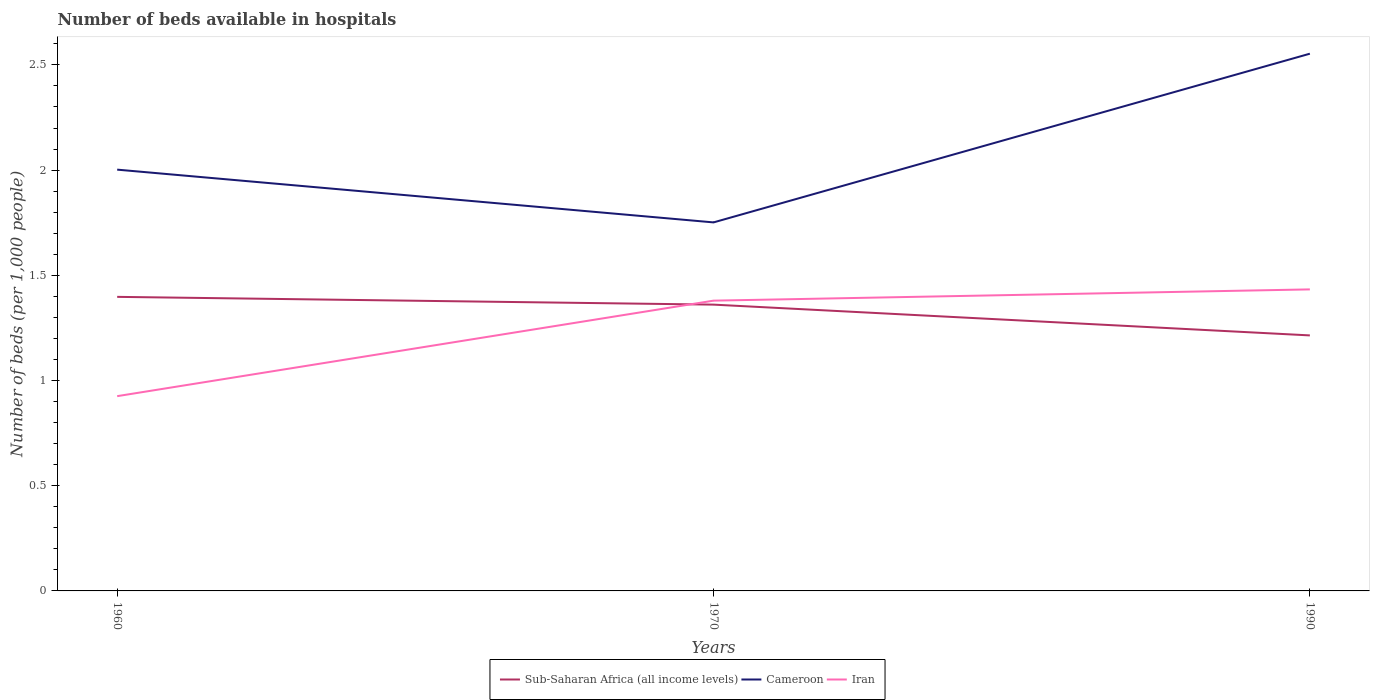How many different coloured lines are there?
Provide a succinct answer. 3. Does the line corresponding to Iran intersect with the line corresponding to Sub-Saharan Africa (all income levels)?
Give a very brief answer. Yes. Is the number of lines equal to the number of legend labels?
Keep it short and to the point. Yes. Across all years, what is the maximum number of beds in the hospiatls of in Cameroon?
Provide a short and direct response. 1.75. What is the total number of beds in the hospiatls of in Iran in the graph?
Keep it short and to the point. -0.05. What is the difference between the highest and the second highest number of beds in the hospiatls of in Iran?
Provide a short and direct response. 0.51. What is the difference between the highest and the lowest number of beds in the hospiatls of in Sub-Saharan Africa (all income levels)?
Offer a very short reply. 2. What is the difference between two consecutive major ticks on the Y-axis?
Keep it short and to the point. 0.5. Where does the legend appear in the graph?
Give a very brief answer. Bottom center. How are the legend labels stacked?
Give a very brief answer. Horizontal. What is the title of the graph?
Ensure brevity in your answer.  Number of beds available in hospitals. Does "Grenada" appear as one of the legend labels in the graph?
Offer a terse response. No. What is the label or title of the Y-axis?
Your answer should be compact. Number of beds (per 1,0 people). What is the Number of beds (per 1,000 people) in Sub-Saharan Africa (all income levels) in 1960?
Give a very brief answer. 1.4. What is the Number of beds (per 1,000 people) in Cameroon in 1960?
Provide a short and direct response. 2. What is the Number of beds (per 1,000 people) of Iran in 1960?
Ensure brevity in your answer.  0.93. What is the Number of beds (per 1,000 people) in Sub-Saharan Africa (all income levels) in 1970?
Give a very brief answer. 1.36. What is the Number of beds (per 1,000 people) of Cameroon in 1970?
Make the answer very short. 1.75. What is the Number of beds (per 1,000 people) in Iran in 1970?
Provide a succinct answer. 1.38. What is the Number of beds (per 1,000 people) in Sub-Saharan Africa (all income levels) in 1990?
Provide a short and direct response. 1.21. What is the Number of beds (per 1,000 people) in Cameroon in 1990?
Keep it short and to the point. 2.55. What is the Number of beds (per 1,000 people) in Iran in 1990?
Ensure brevity in your answer.  1.43. Across all years, what is the maximum Number of beds (per 1,000 people) in Sub-Saharan Africa (all income levels)?
Provide a succinct answer. 1.4. Across all years, what is the maximum Number of beds (per 1,000 people) in Cameroon?
Offer a very short reply. 2.55. Across all years, what is the maximum Number of beds (per 1,000 people) of Iran?
Offer a terse response. 1.43. Across all years, what is the minimum Number of beds (per 1,000 people) in Sub-Saharan Africa (all income levels)?
Offer a terse response. 1.21. Across all years, what is the minimum Number of beds (per 1,000 people) in Cameroon?
Make the answer very short. 1.75. Across all years, what is the minimum Number of beds (per 1,000 people) in Iran?
Make the answer very short. 0.93. What is the total Number of beds (per 1,000 people) of Sub-Saharan Africa (all income levels) in the graph?
Keep it short and to the point. 3.97. What is the total Number of beds (per 1,000 people) of Cameroon in the graph?
Keep it short and to the point. 6.31. What is the total Number of beds (per 1,000 people) of Iran in the graph?
Make the answer very short. 3.74. What is the difference between the Number of beds (per 1,000 people) of Sub-Saharan Africa (all income levels) in 1960 and that in 1970?
Your response must be concise. 0.04. What is the difference between the Number of beds (per 1,000 people) of Cameroon in 1960 and that in 1970?
Offer a terse response. 0.25. What is the difference between the Number of beds (per 1,000 people) in Iran in 1960 and that in 1970?
Offer a very short reply. -0.45. What is the difference between the Number of beds (per 1,000 people) in Sub-Saharan Africa (all income levels) in 1960 and that in 1990?
Keep it short and to the point. 0.18. What is the difference between the Number of beds (per 1,000 people) in Cameroon in 1960 and that in 1990?
Offer a very short reply. -0.55. What is the difference between the Number of beds (per 1,000 people) in Iran in 1960 and that in 1990?
Provide a succinct answer. -0.51. What is the difference between the Number of beds (per 1,000 people) of Sub-Saharan Africa (all income levels) in 1970 and that in 1990?
Give a very brief answer. 0.15. What is the difference between the Number of beds (per 1,000 people) in Cameroon in 1970 and that in 1990?
Provide a short and direct response. -0.8. What is the difference between the Number of beds (per 1,000 people) in Iran in 1970 and that in 1990?
Offer a very short reply. -0.05. What is the difference between the Number of beds (per 1,000 people) of Sub-Saharan Africa (all income levels) in 1960 and the Number of beds (per 1,000 people) of Cameroon in 1970?
Keep it short and to the point. -0.35. What is the difference between the Number of beds (per 1,000 people) in Sub-Saharan Africa (all income levels) in 1960 and the Number of beds (per 1,000 people) in Iran in 1970?
Your answer should be compact. 0.02. What is the difference between the Number of beds (per 1,000 people) of Cameroon in 1960 and the Number of beds (per 1,000 people) of Iran in 1970?
Make the answer very short. 0.62. What is the difference between the Number of beds (per 1,000 people) of Sub-Saharan Africa (all income levels) in 1960 and the Number of beds (per 1,000 people) of Cameroon in 1990?
Offer a terse response. -1.16. What is the difference between the Number of beds (per 1,000 people) in Sub-Saharan Africa (all income levels) in 1960 and the Number of beds (per 1,000 people) in Iran in 1990?
Make the answer very short. -0.04. What is the difference between the Number of beds (per 1,000 people) in Cameroon in 1960 and the Number of beds (per 1,000 people) in Iran in 1990?
Provide a short and direct response. 0.57. What is the difference between the Number of beds (per 1,000 people) in Sub-Saharan Africa (all income levels) in 1970 and the Number of beds (per 1,000 people) in Cameroon in 1990?
Give a very brief answer. -1.19. What is the difference between the Number of beds (per 1,000 people) of Sub-Saharan Africa (all income levels) in 1970 and the Number of beds (per 1,000 people) of Iran in 1990?
Your answer should be compact. -0.07. What is the difference between the Number of beds (per 1,000 people) of Cameroon in 1970 and the Number of beds (per 1,000 people) of Iran in 1990?
Offer a terse response. 0.32. What is the average Number of beds (per 1,000 people) in Sub-Saharan Africa (all income levels) per year?
Provide a short and direct response. 1.32. What is the average Number of beds (per 1,000 people) in Cameroon per year?
Your answer should be compact. 2.1. What is the average Number of beds (per 1,000 people) of Iran per year?
Offer a very short reply. 1.25. In the year 1960, what is the difference between the Number of beds (per 1,000 people) in Sub-Saharan Africa (all income levels) and Number of beds (per 1,000 people) in Cameroon?
Ensure brevity in your answer.  -0.6. In the year 1960, what is the difference between the Number of beds (per 1,000 people) in Sub-Saharan Africa (all income levels) and Number of beds (per 1,000 people) in Iran?
Offer a terse response. 0.47. In the year 1960, what is the difference between the Number of beds (per 1,000 people) in Cameroon and Number of beds (per 1,000 people) in Iran?
Give a very brief answer. 1.08. In the year 1970, what is the difference between the Number of beds (per 1,000 people) in Sub-Saharan Africa (all income levels) and Number of beds (per 1,000 people) in Cameroon?
Ensure brevity in your answer.  -0.39. In the year 1970, what is the difference between the Number of beds (per 1,000 people) of Sub-Saharan Africa (all income levels) and Number of beds (per 1,000 people) of Iran?
Offer a terse response. -0.02. In the year 1970, what is the difference between the Number of beds (per 1,000 people) of Cameroon and Number of beds (per 1,000 people) of Iran?
Provide a short and direct response. 0.37. In the year 1990, what is the difference between the Number of beds (per 1,000 people) in Sub-Saharan Africa (all income levels) and Number of beds (per 1,000 people) in Cameroon?
Provide a succinct answer. -1.34. In the year 1990, what is the difference between the Number of beds (per 1,000 people) of Sub-Saharan Africa (all income levels) and Number of beds (per 1,000 people) of Iran?
Provide a succinct answer. -0.22. In the year 1990, what is the difference between the Number of beds (per 1,000 people) in Cameroon and Number of beds (per 1,000 people) in Iran?
Offer a very short reply. 1.12. What is the ratio of the Number of beds (per 1,000 people) of Sub-Saharan Africa (all income levels) in 1960 to that in 1970?
Your response must be concise. 1.03. What is the ratio of the Number of beds (per 1,000 people) of Cameroon in 1960 to that in 1970?
Make the answer very short. 1.14. What is the ratio of the Number of beds (per 1,000 people) of Iran in 1960 to that in 1970?
Keep it short and to the point. 0.67. What is the ratio of the Number of beds (per 1,000 people) of Sub-Saharan Africa (all income levels) in 1960 to that in 1990?
Keep it short and to the point. 1.15. What is the ratio of the Number of beds (per 1,000 people) of Cameroon in 1960 to that in 1990?
Keep it short and to the point. 0.78. What is the ratio of the Number of beds (per 1,000 people) of Iran in 1960 to that in 1990?
Offer a very short reply. 0.65. What is the ratio of the Number of beds (per 1,000 people) in Sub-Saharan Africa (all income levels) in 1970 to that in 1990?
Provide a succinct answer. 1.12. What is the ratio of the Number of beds (per 1,000 people) in Cameroon in 1970 to that in 1990?
Provide a succinct answer. 0.69. What is the ratio of the Number of beds (per 1,000 people) in Iran in 1970 to that in 1990?
Your answer should be compact. 0.96. What is the difference between the highest and the second highest Number of beds (per 1,000 people) in Sub-Saharan Africa (all income levels)?
Provide a short and direct response. 0.04. What is the difference between the highest and the second highest Number of beds (per 1,000 people) in Cameroon?
Give a very brief answer. 0.55. What is the difference between the highest and the second highest Number of beds (per 1,000 people) in Iran?
Make the answer very short. 0.05. What is the difference between the highest and the lowest Number of beds (per 1,000 people) of Sub-Saharan Africa (all income levels)?
Keep it short and to the point. 0.18. What is the difference between the highest and the lowest Number of beds (per 1,000 people) of Cameroon?
Your answer should be very brief. 0.8. What is the difference between the highest and the lowest Number of beds (per 1,000 people) in Iran?
Your response must be concise. 0.51. 